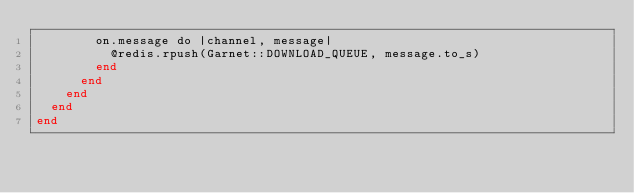Convert code to text. <code><loc_0><loc_0><loc_500><loc_500><_Crystal_>        on.message do |channel, message|
          @redis.rpush(Garnet::DOWNLOAD_QUEUE, message.to_s)
        end
      end
    end
  end
end
</code> 